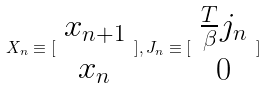Convert formula to latex. <formula><loc_0><loc_0><loc_500><loc_500>X _ { n } \equiv [ \begin{array} { c } x _ { n + 1 } \\ x _ { n } \end{array} ] , J _ { n } \equiv [ \begin{array} { c } \frac { T } { \beta } j _ { n } \\ 0 \end{array} ]</formula> 